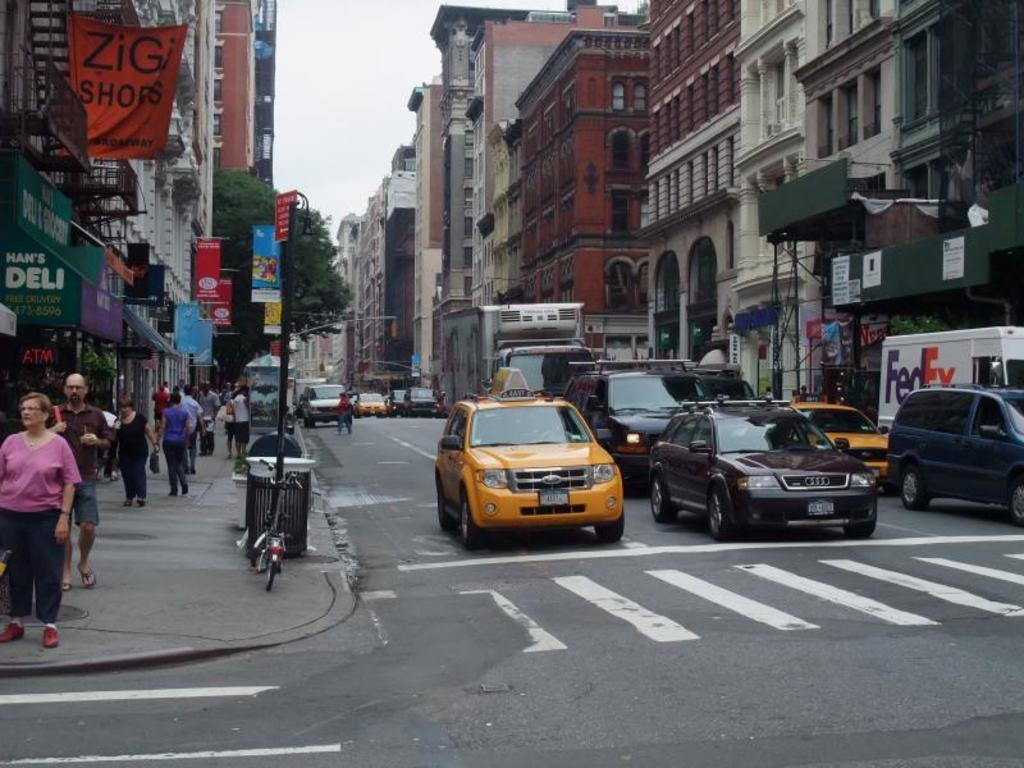Is that a deli to the left?
Keep it short and to the point. Yes. 